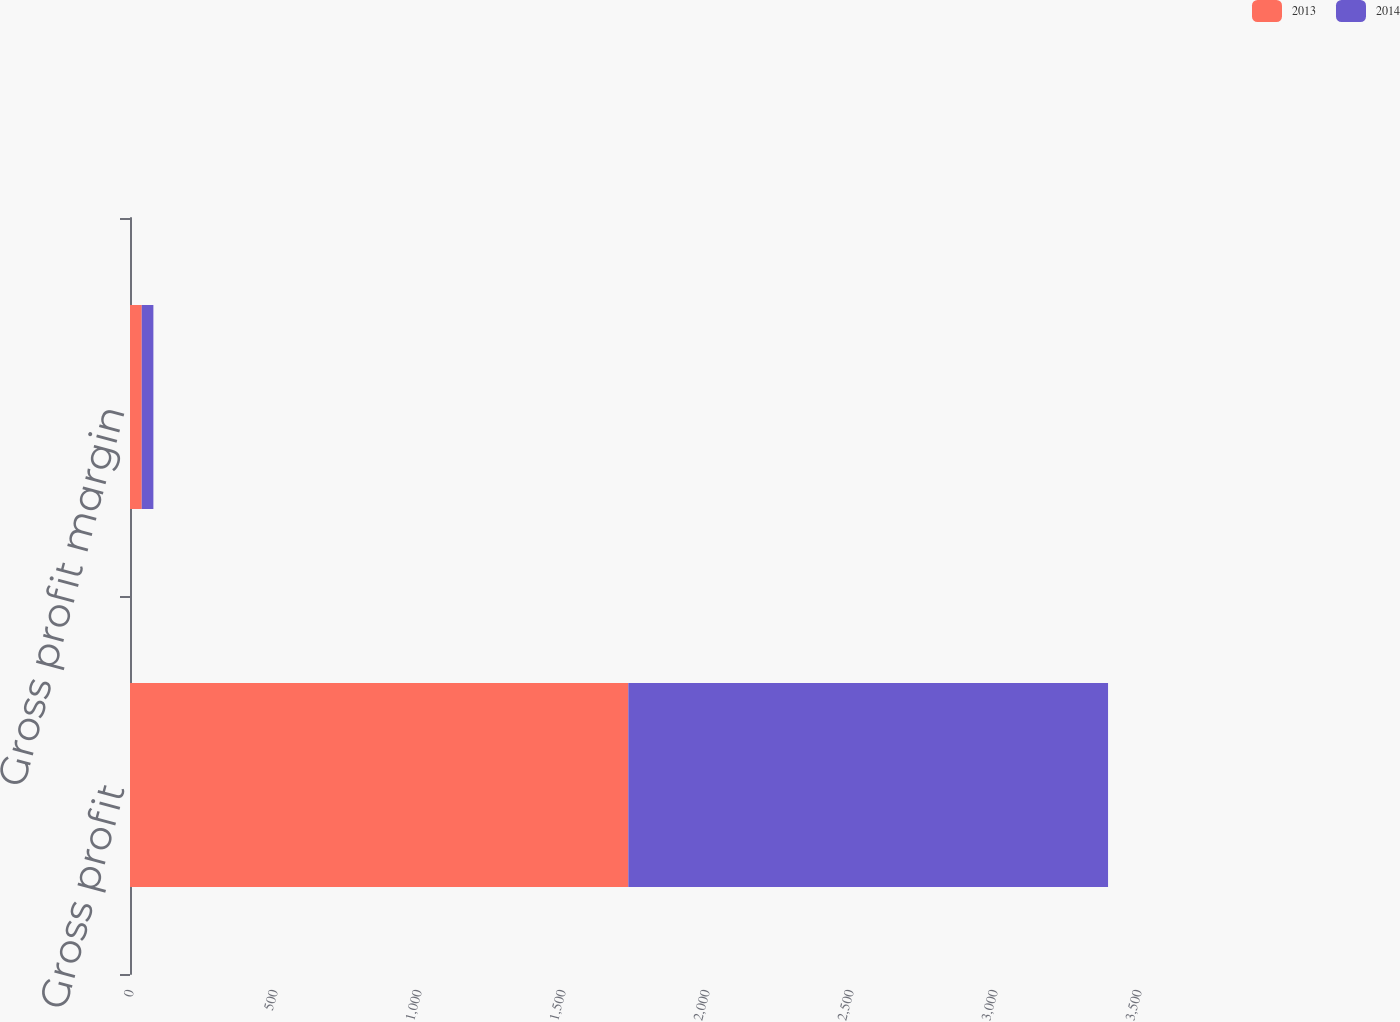Convert chart. <chart><loc_0><loc_0><loc_500><loc_500><stacked_bar_chart><ecel><fcel>Gross profit<fcel>Gross profit margin<nl><fcel>2013<fcel>1730.2<fcel>40.8<nl><fcel>2014<fcel>1665.8<fcel>40.4<nl></chart> 